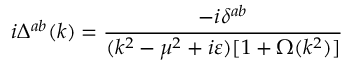Convert formula to latex. <formula><loc_0><loc_0><loc_500><loc_500>i \Delta ^ { a b } ( k ) = \frac { - i \delta ^ { a b } } { ( k ^ { 2 } - \mu ^ { 2 } + i \varepsilon ) [ 1 + \Omega ( k ^ { 2 } ) ] }</formula> 